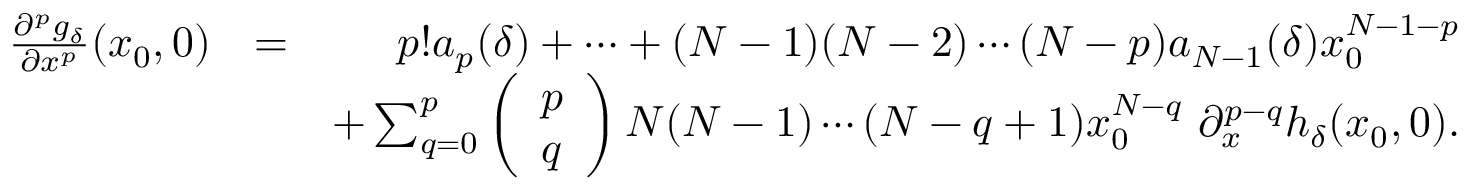<formula> <loc_0><loc_0><loc_500><loc_500>\begin{array} { r l r } { \frac { \partial ^ { p } g _ { \delta } } { \partial x ^ { p } } ( x _ { 0 } , 0 ) } & { = } & { p ! a _ { p } ( \delta ) + \cdots + ( N - 1 ) ( N - 2 ) \cdots ( N - p ) a _ { N - 1 } ( \delta ) x _ { 0 } ^ { N - 1 - p } } \\ & { + \sum _ { q = 0 } ^ { p } \left ( \begin{array} { l } { p } \\ { q } \end{array} \right ) N ( N - 1 ) \cdots ( N - q + 1 ) x _ { 0 } ^ { N - q } \ \partial _ { x } ^ { p - q } h _ { \delta } ( x _ { 0 } , 0 ) . } \end{array}</formula> 